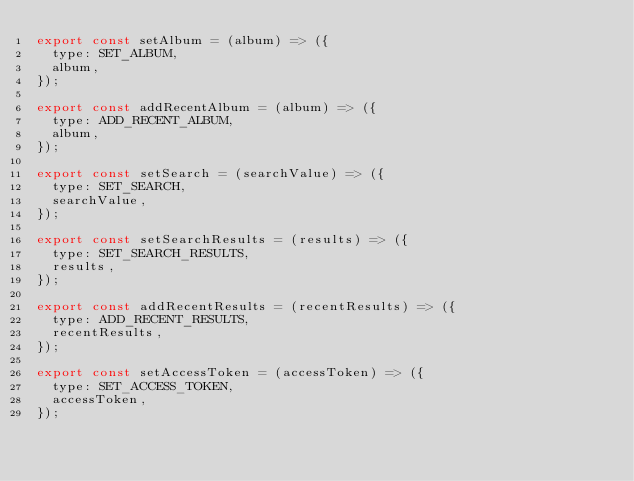<code> <loc_0><loc_0><loc_500><loc_500><_JavaScript_>export const setAlbum = (album) => ({
  type: SET_ALBUM,
  album,
});

export const addRecentAlbum = (album) => ({
  type: ADD_RECENT_ALBUM,
  album,
});

export const setSearch = (searchValue) => ({
  type: SET_SEARCH,
  searchValue,
});

export const setSearchResults = (results) => ({
  type: SET_SEARCH_RESULTS,
  results,
});

export const addRecentResults = (recentResults) => ({
  type: ADD_RECENT_RESULTS,
  recentResults,
});

export const setAccessToken = (accessToken) => ({
  type: SET_ACCESS_TOKEN,
  accessToken,
});
</code> 